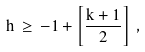Convert formula to latex. <formula><loc_0><loc_0><loc_500><loc_500>h \, \geq \, - 1 + \left [ \frac { k + 1 } { 2 } \right ] \, ,</formula> 